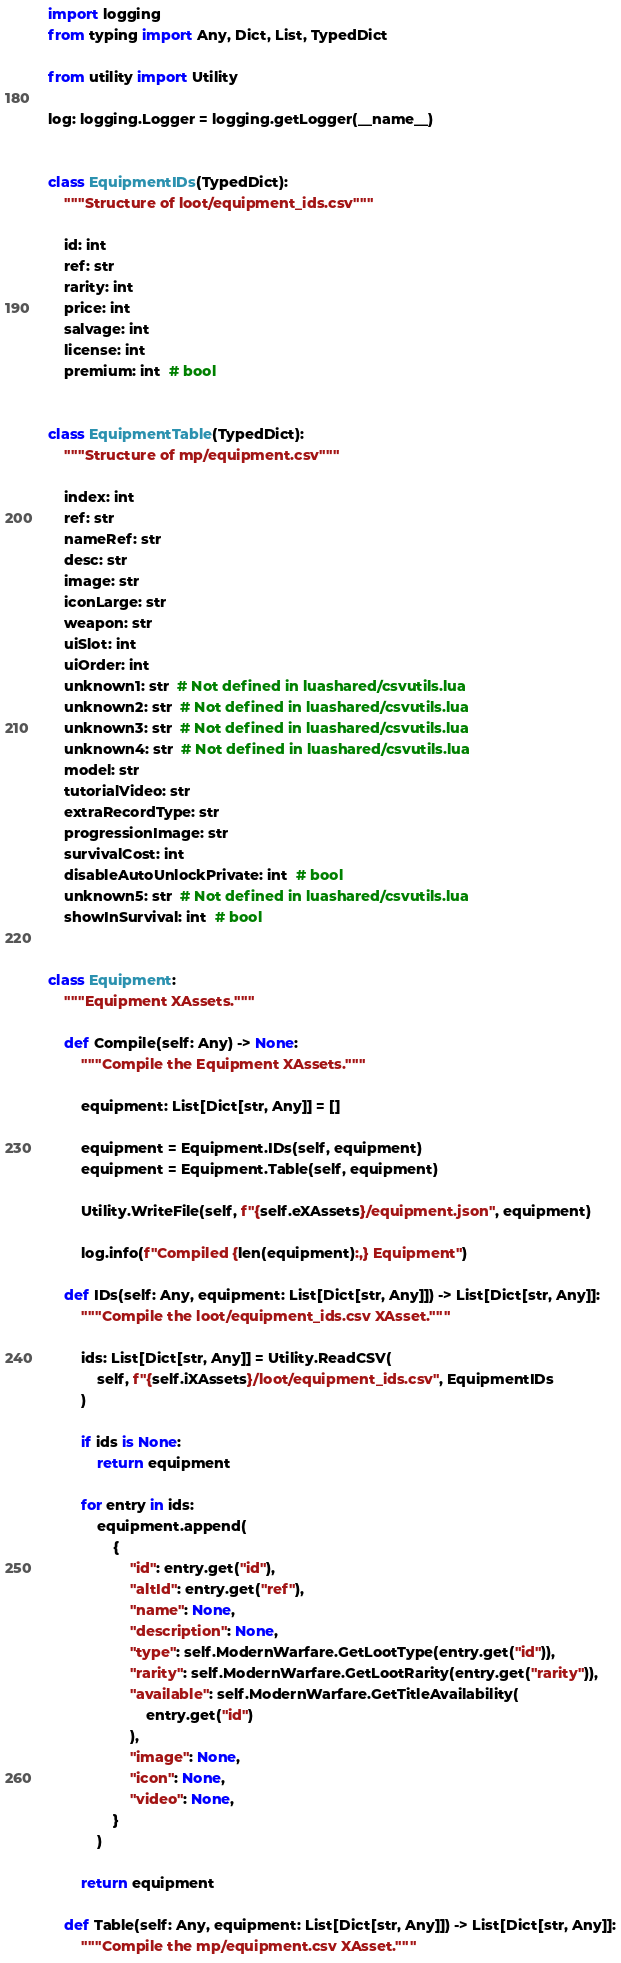<code> <loc_0><loc_0><loc_500><loc_500><_Python_>import logging
from typing import Any, Dict, List, TypedDict

from utility import Utility

log: logging.Logger = logging.getLogger(__name__)


class EquipmentIDs(TypedDict):
    """Structure of loot/equipment_ids.csv"""

    id: int
    ref: str
    rarity: int
    price: int
    salvage: int
    license: int
    premium: int  # bool


class EquipmentTable(TypedDict):
    """Structure of mp/equipment.csv"""

    index: int
    ref: str
    nameRef: str
    desc: str
    image: str
    iconLarge: str
    weapon: str
    uiSlot: int
    uiOrder: int
    unknown1: str  # Not defined in luashared/csvutils.lua
    unknown2: str  # Not defined in luashared/csvutils.lua
    unknown3: str  # Not defined in luashared/csvutils.lua
    unknown4: str  # Not defined in luashared/csvutils.lua
    model: str
    tutorialVideo: str
    extraRecordType: str
    progressionImage: str
    survivalCost: int
    disableAutoUnlockPrivate: int  # bool
    unknown5: str  # Not defined in luashared/csvutils.lua
    showInSurvival: int  # bool


class Equipment:
    """Equipment XAssets."""

    def Compile(self: Any) -> None:
        """Compile the Equipment XAssets."""

        equipment: List[Dict[str, Any]] = []

        equipment = Equipment.IDs(self, equipment)
        equipment = Equipment.Table(self, equipment)

        Utility.WriteFile(self, f"{self.eXAssets}/equipment.json", equipment)

        log.info(f"Compiled {len(equipment):,} Equipment")

    def IDs(self: Any, equipment: List[Dict[str, Any]]) -> List[Dict[str, Any]]:
        """Compile the loot/equipment_ids.csv XAsset."""

        ids: List[Dict[str, Any]] = Utility.ReadCSV(
            self, f"{self.iXAssets}/loot/equipment_ids.csv", EquipmentIDs
        )

        if ids is None:
            return equipment

        for entry in ids:
            equipment.append(
                {
                    "id": entry.get("id"),
                    "altId": entry.get("ref"),
                    "name": None,
                    "description": None,
                    "type": self.ModernWarfare.GetLootType(entry.get("id")),
                    "rarity": self.ModernWarfare.GetLootRarity(entry.get("rarity")),
                    "available": self.ModernWarfare.GetTitleAvailability(
                        entry.get("id")
                    ),
                    "image": None,
                    "icon": None,
                    "video": None,
                }
            )

        return equipment

    def Table(self: Any, equipment: List[Dict[str, Any]]) -> List[Dict[str, Any]]:
        """Compile the mp/equipment.csv XAsset."""
</code> 